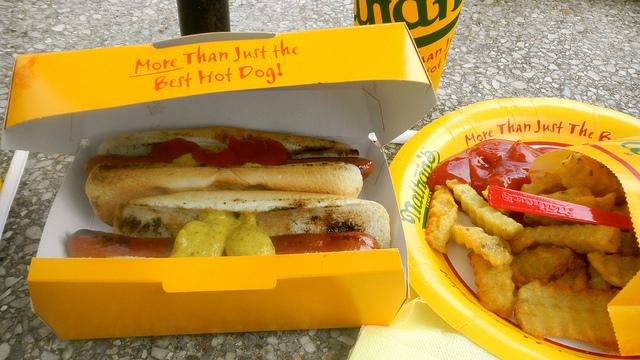Is there ketchup on the food?
Short answer required. Yes. What restaurant did this food come from?
Give a very brief answer. Nathan's. What food's are shown?
Write a very short answer. Hot dogs and fries. 